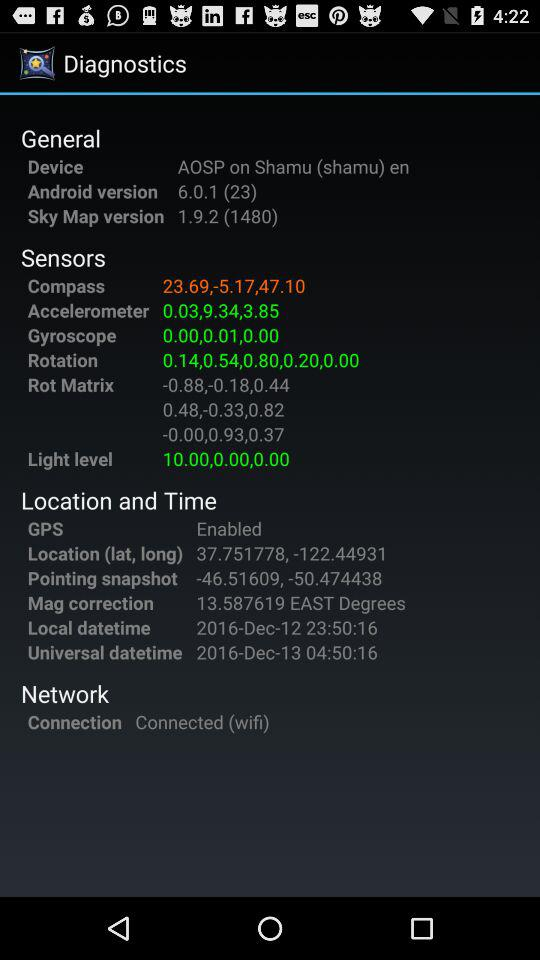How many network connections are available?
When the provided information is insufficient, respond with <no answer>. <no answer> 